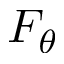Convert formula to latex. <formula><loc_0><loc_0><loc_500><loc_500>F _ { \theta }</formula> 